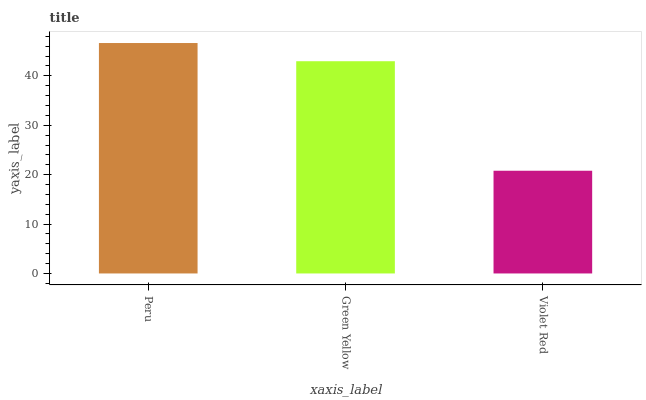Is Violet Red the minimum?
Answer yes or no. Yes. Is Peru the maximum?
Answer yes or no. Yes. Is Green Yellow the minimum?
Answer yes or no. No. Is Green Yellow the maximum?
Answer yes or no. No. Is Peru greater than Green Yellow?
Answer yes or no. Yes. Is Green Yellow less than Peru?
Answer yes or no. Yes. Is Green Yellow greater than Peru?
Answer yes or no. No. Is Peru less than Green Yellow?
Answer yes or no. No. Is Green Yellow the high median?
Answer yes or no. Yes. Is Green Yellow the low median?
Answer yes or no. Yes. Is Peru the high median?
Answer yes or no. No. Is Peru the low median?
Answer yes or no. No. 